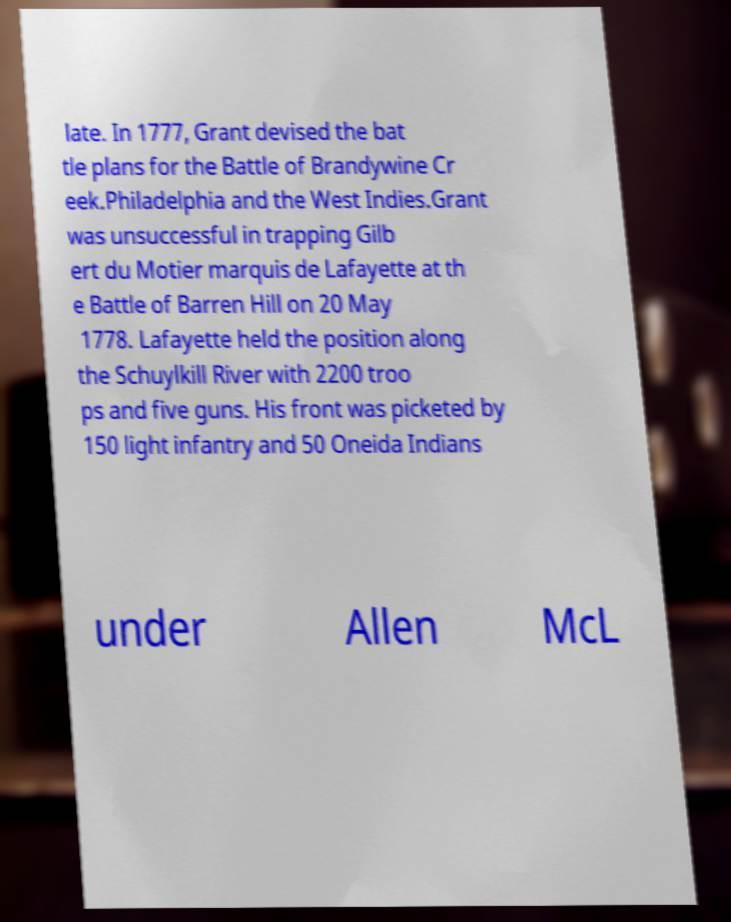For documentation purposes, I need the text within this image transcribed. Could you provide that? late. In 1777, Grant devised the bat tle plans for the Battle of Brandywine Cr eek.Philadelphia and the West Indies.Grant was unsuccessful in trapping Gilb ert du Motier marquis de Lafayette at th e Battle of Barren Hill on 20 May 1778. Lafayette held the position along the Schuylkill River with 2200 troo ps and five guns. His front was picketed by 150 light infantry and 50 Oneida Indians under Allen McL 